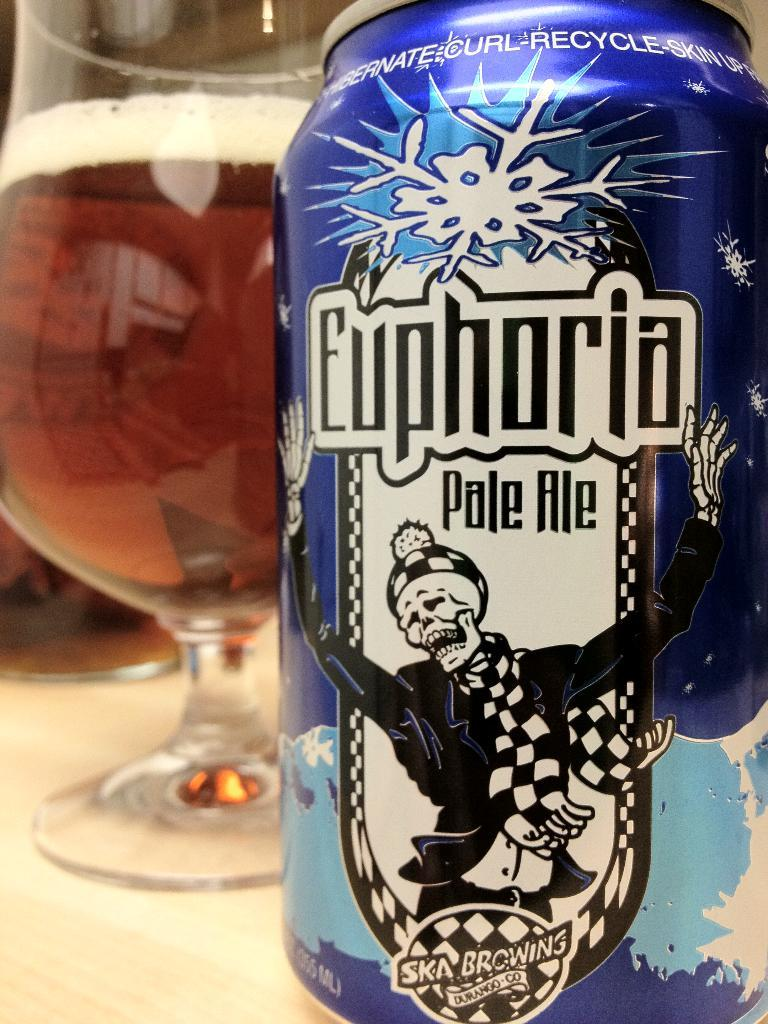<image>
Share a concise interpretation of the image provided. A can of Euphoria pale ale sits in front of a nearly full glass of beer. 